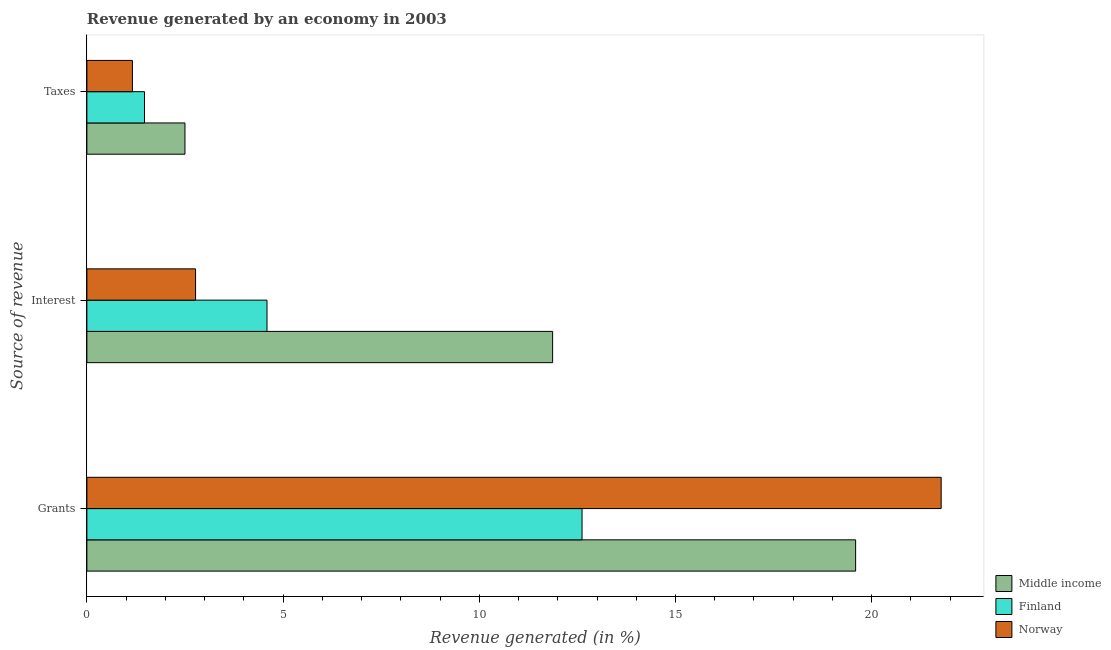How many different coloured bars are there?
Give a very brief answer. 3. How many groups of bars are there?
Make the answer very short. 3. Are the number of bars on each tick of the Y-axis equal?
Ensure brevity in your answer.  Yes. What is the label of the 2nd group of bars from the top?
Your response must be concise. Interest. What is the percentage of revenue generated by interest in Norway?
Your answer should be compact. 2.77. Across all countries, what is the maximum percentage of revenue generated by interest?
Give a very brief answer. 11.87. Across all countries, what is the minimum percentage of revenue generated by taxes?
Your answer should be very brief. 1.16. In which country was the percentage of revenue generated by taxes maximum?
Make the answer very short. Middle income. In which country was the percentage of revenue generated by interest minimum?
Your answer should be compact. Norway. What is the total percentage of revenue generated by taxes in the graph?
Ensure brevity in your answer.  5.13. What is the difference between the percentage of revenue generated by interest in Middle income and that in Finland?
Your response must be concise. 7.28. What is the difference between the percentage of revenue generated by interest in Norway and the percentage of revenue generated by taxes in Finland?
Your answer should be compact. 1.3. What is the average percentage of revenue generated by taxes per country?
Provide a short and direct response. 1.71. What is the difference between the percentage of revenue generated by interest and percentage of revenue generated by grants in Finland?
Provide a succinct answer. -8.03. In how many countries, is the percentage of revenue generated by taxes greater than 14 %?
Make the answer very short. 0. What is the ratio of the percentage of revenue generated by grants in Middle income to that in Norway?
Provide a short and direct response. 0.9. What is the difference between the highest and the second highest percentage of revenue generated by interest?
Make the answer very short. 7.28. What is the difference between the highest and the lowest percentage of revenue generated by interest?
Offer a terse response. 9.1. What does the 1st bar from the bottom in Taxes represents?
Give a very brief answer. Middle income. Is it the case that in every country, the sum of the percentage of revenue generated by grants and percentage of revenue generated by interest is greater than the percentage of revenue generated by taxes?
Offer a terse response. Yes. How many bars are there?
Your answer should be compact. 9. Are all the bars in the graph horizontal?
Your answer should be very brief. Yes. What is the difference between two consecutive major ticks on the X-axis?
Give a very brief answer. 5. Are the values on the major ticks of X-axis written in scientific E-notation?
Offer a terse response. No. Does the graph contain grids?
Provide a short and direct response. No. Where does the legend appear in the graph?
Give a very brief answer. Bottom right. How many legend labels are there?
Ensure brevity in your answer.  3. What is the title of the graph?
Your answer should be very brief. Revenue generated by an economy in 2003. What is the label or title of the X-axis?
Ensure brevity in your answer.  Revenue generated (in %). What is the label or title of the Y-axis?
Offer a terse response. Source of revenue. What is the Revenue generated (in %) of Middle income in Grants?
Offer a terse response. 19.59. What is the Revenue generated (in %) of Finland in Grants?
Keep it short and to the point. 12.62. What is the Revenue generated (in %) of Norway in Grants?
Keep it short and to the point. 21.77. What is the Revenue generated (in %) in Middle income in Interest?
Offer a very short reply. 11.87. What is the Revenue generated (in %) in Finland in Interest?
Give a very brief answer. 4.59. What is the Revenue generated (in %) of Norway in Interest?
Keep it short and to the point. 2.77. What is the Revenue generated (in %) in Middle income in Taxes?
Ensure brevity in your answer.  2.5. What is the Revenue generated (in %) of Finland in Taxes?
Make the answer very short. 1.47. What is the Revenue generated (in %) of Norway in Taxes?
Provide a succinct answer. 1.16. Across all Source of revenue, what is the maximum Revenue generated (in %) in Middle income?
Give a very brief answer. 19.59. Across all Source of revenue, what is the maximum Revenue generated (in %) in Finland?
Your response must be concise. 12.62. Across all Source of revenue, what is the maximum Revenue generated (in %) of Norway?
Make the answer very short. 21.77. Across all Source of revenue, what is the minimum Revenue generated (in %) in Middle income?
Your response must be concise. 2.5. Across all Source of revenue, what is the minimum Revenue generated (in %) of Finland?
Ensure brevity in your answer.  1.47. Across all Source of revenue, what is the minimum Revenue generated (in %) of Norway?
Provide a short and direct response. 1.16. What is the total Revenue generated (in %) of Middle income in the graph?
Your answer should be very brief. 33.96. What is the total Revenue generated (in %) in Finland in the graph?
Your response must be concise. 18.68. What is the total Revenue generated (in %) in Norway in the graph?
Provide a succinct answer. 25.7. What is the difference between the Revenue generated (in %) of Middle income in Grants and that in Interest?
Ensure brevity in your answer.  7.72. What is the difference between the Revenue generated (in %) of Finland in Grants and that in Interest?
Your response must be concise. 8.03. What is the difference between the Revenue generated (in %) of Norway in Grants and that in Interest?
Your answer should be compact. 19. What is the difference between the Revenue generated (in %) of Middle income in Grants and that in Taxes?
Your answer should be very brief. 17.09. What is the difference between the Revenue generated (in %) in Finland in Grants and that in Taxes?
Your answer should be very brief. 11.15. What is the difference between the Revenue generated (in %) of Norway in Grants and that in Taxes?
Keep it short and to the point. 20.61. What is the difference between the Revenue generated (in %) in Middle income in Interest and that in Taxes?
Give a very brief answer. 9.37. What is the difference between the Revenue generated (in %) of Finland in Interest and that in Taxes?
Provide a short and direct response. 3.12. What is the difference between the Revenue generated (in %) of Norway in Interest and that in Taxes?
Your answer should be very brief. 1.61. What is the difference between the Revenue generated (in %) of Middle income in Grants and the Revenue generated (in %) of Finland in Interest?
Ensure brevity in your answer.  15. What is the difference between the Revenue generated (in %) in Middle income in Grants and the Revenue generated (in %) in Norway in Interest?
Keep it short and to the point. 16.82. What is the difference between the Revenue generated (in %) of Finland in Grants and the Revenue generated (in %) of Norway in Interest?
Keep it short and to the point. 9.85. What is the difference between the Revenue generated (in %) in Middle income in Grants and the Revenue generated (in %) in Finland in Taxes?
Your answer should be very brief. 18.12. What is the difference between the Revenue generated (in %) in Middle income in Grants and the Revenue generated (in %) in Norway in Taxes?
Provide a succinct answer. 18.43. What is the difference between the Revenue generated (in %) in Finland in Grants and the Revenue generated (in %) in Norway in Taxes?
Give a very brief answer. 11.46. What is the difference between the Revenue generated (in %) of Middle income in Interest and the Revenue generated (in %) of Finland in Taxes?
Make the answer very short. 10.4. What is the difference between the Revenue generated (in %) in Middle income in Interest and the Revenue generated (in %) in Norway in Taxes?
Your answer should be very brief. 10.71. What is the difference between the Revenue generated (in %) of Finland in Interest and the Revenue generated (in %) of Norway in Taxes?
Offer a very short reply. 3.43. What is the average Revenue generated (in %) in Middle income per Source of revenue?
Your answer should be compact. 11.32. What is the average Revenue generated (in %) in Finland per Source of revenue?
Provide a succinct answer. 6.23. What is the average Revenue generated (in %) in Norway per Source of revenue?
Offer a very short reply. 8.57. What is the difference between the Revenue generated (in %) of Middle income and Revenue generated (in %) of Finland in Grants?
Your answer should be compact. 6.97. What is the difference between the Revenue generated (in %) of Middle income and Revenue generated (in %) of Norway in Grants?
Ensure brevity in your answer.  -2.18. What is the difference between the Revenue generated (in %) of Finland and Revenue generated (in %) of Norway in Grants?
Ensure brevity in your answer.  -9.15. What is the difference between the Revenue generated (in %) in Middle income and Revenue generated (in %) in Finland in Interest?
Your answer should be compact. 7.28. What is the difference between the Revenue generated (in %) in Middle income and Revenue generated (in %) in Norway in Interest?
Offer a very short reply. 9.1. What is the difference between the Revenue generated (in %) of Finland and Revenue generated (in %) of Norway in Interest?
Offer a very short reply. 1.82. What is the difference between the Revenue generated (in %) of Middle income and Revenue generated (in %) of Finland in Taxes?
Make the answer very short. 1.03. What is the difference between the Revenue generated (in %) in Middle income and Revenue generated (in %) in Norway in Taxes?
Your response must be concise. 1.34. What is the difference between the Revenue generated (in %) of Finland and Revenue generated (in %) of Norway in Taxes?
Offer a terse response. 0.31. What is the ratio of the Revenue generated (in %) in Middle income in Grants to that in Interest?
Offer a terse response. 1.65. What is the ratio of the Revenue generated (in %) in Finland in Grants to that in Interest?
Offer a very short reply. 2.75. What is the ratio of the Revenue generated (in %) in Norway in Grants to that in Interest?
Your response must be concise. 7.86. What is the ratio of the Revenue generated (in %) of Middle income in Grants to that in Taxes?
Ensure brevity in your answer.  7.84. What is the ratio of the Revenue generated (in %) in Finland in Grants to that in Taxes?
Offer a terse response. 8.59. What is the ratio of the Revenue generated (in %) of Norway in Grants to that in Taxes?
Offer a terse response. 18.76. What is the ratio of the Revenue generated (in %) in Middle income in Interest to that in Taxes?
Provide a short and direct response. 4.75. What is the ratio of the Revenue generated (in %) of Finland in Interest to that in Taxes?
Offer a very short reply. 3.12. What is the ratio of the Revenue generated (in %) of Norway in Interest to that in Taxes?
Your answer should be very brief. 2.39. What is the difference between the highest and the second highest Revenue generated (in %) in Middle income?
Your answer should be compact. 7.72. What is the difference between the highest and the second highest Revenue generated (in %) in Finland?
Provide a succinct answer. 8.03. What is the difference between the highest and the second highest Revenue generated (in %) in Norway?
Give a very brief answer. 19. What is the difference between the highest and the lowest Revenue generated (in %) in Middle income?
Keep it short and to the point. 17.09. What is the difference between the highest and the lowest Revenue generated (in %) in Finland?
Keep it short and to the point. 11.15. What is the difference between the highest and the lowest Revenue generated (in %) in Norway?
Ensure brevity in your answer.  20.61. 